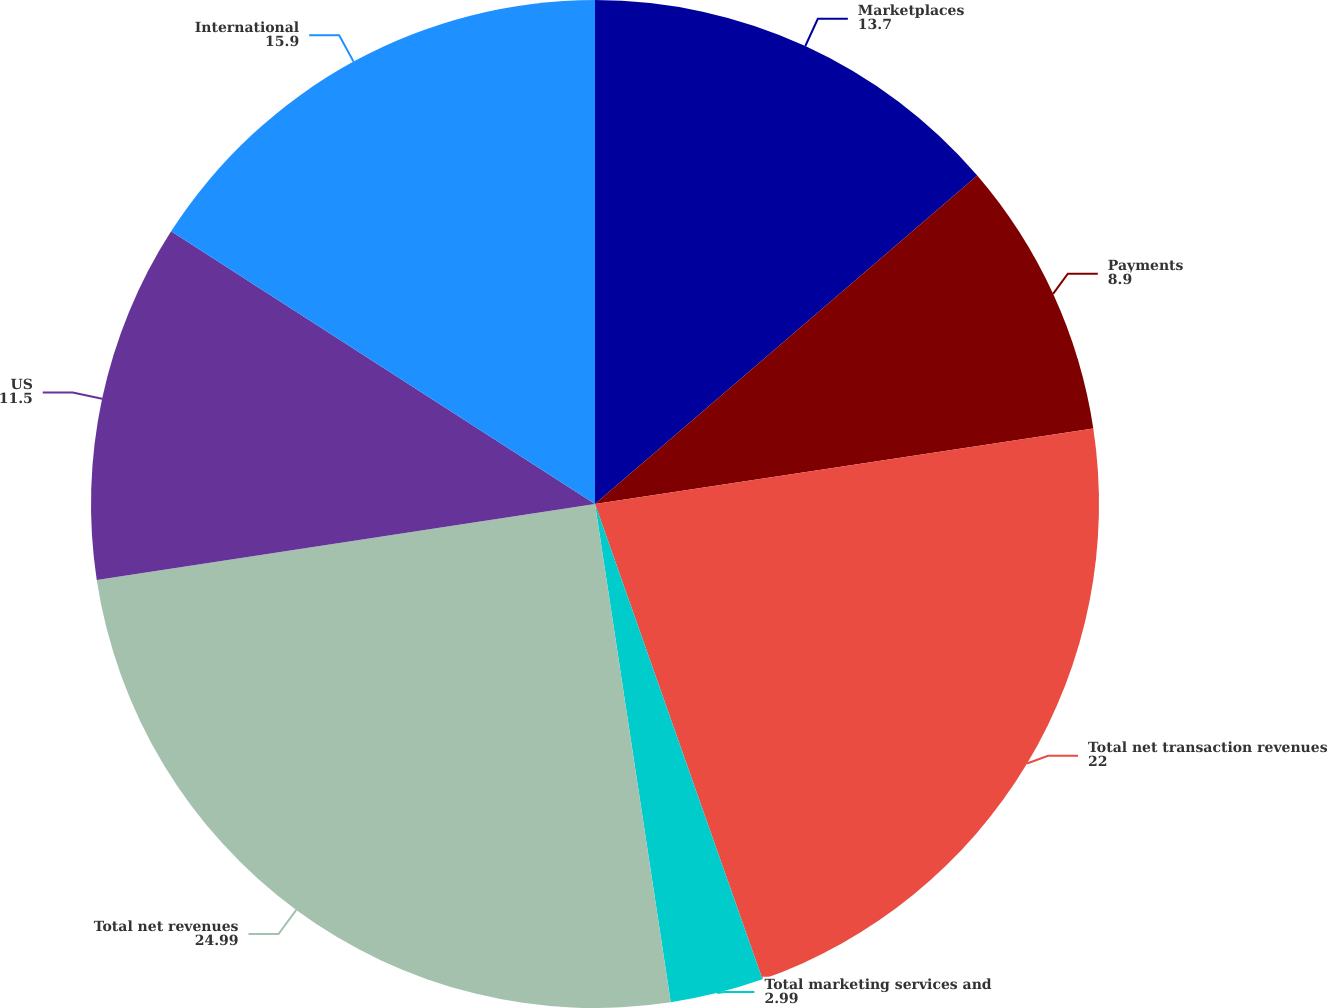Convert chart to OTSL. <chart><loc_0><loc_0><loc_500><loc_500><pie_chart><fcel>Marketplaces<fcel>Payments<fcel>Total net transaction revenues<fcel>Total marketing services and<fcel>Total net revenues<fcel>US<fcel>International<nl><fcel>13.7%<fcel>8.9%<fcel>22.0%<fcel>2.99%<fcel>24.99%<fcel>11.5%<fcel>15.9%<nl></chart> 